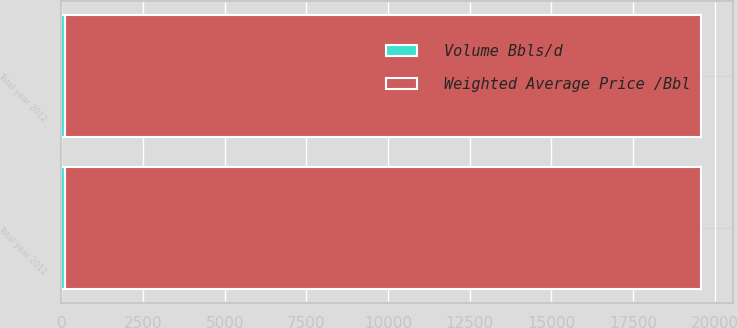Convert chart to OTSL. <chart><loc_0><loc_0><loc_500><loc_500><stacked_bar_chart><ecel><fcel>Total year 2011<fcel>Total year 2012<nl><fcel>Weighted Average Price /Bbl<fcel>19500<fcel>19500<nl><fcel>Volume Bbls/d<fcel>95<fcel>95<nl></chart> 